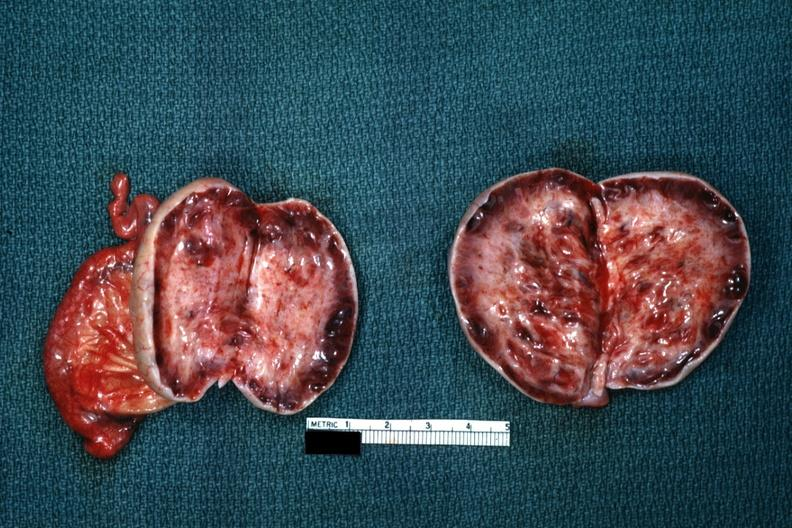s amputation stump infected present?
Answer the question using a single word or phrase. No 